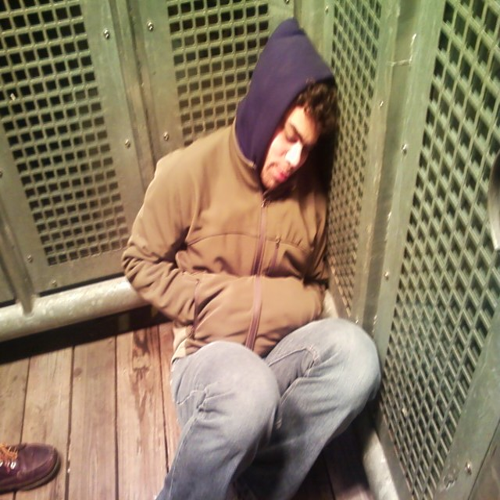What might be the reason this person is sleeping in a public place? There could be several reasons why someone might need to sleep in a public place. They could be exhausted from a long journey, waiting for a delayed transport, or perhaps they found themselves in a situation where they had no alternative but to rest where they are. It would be important to understand the context to provide a more precise answer. 